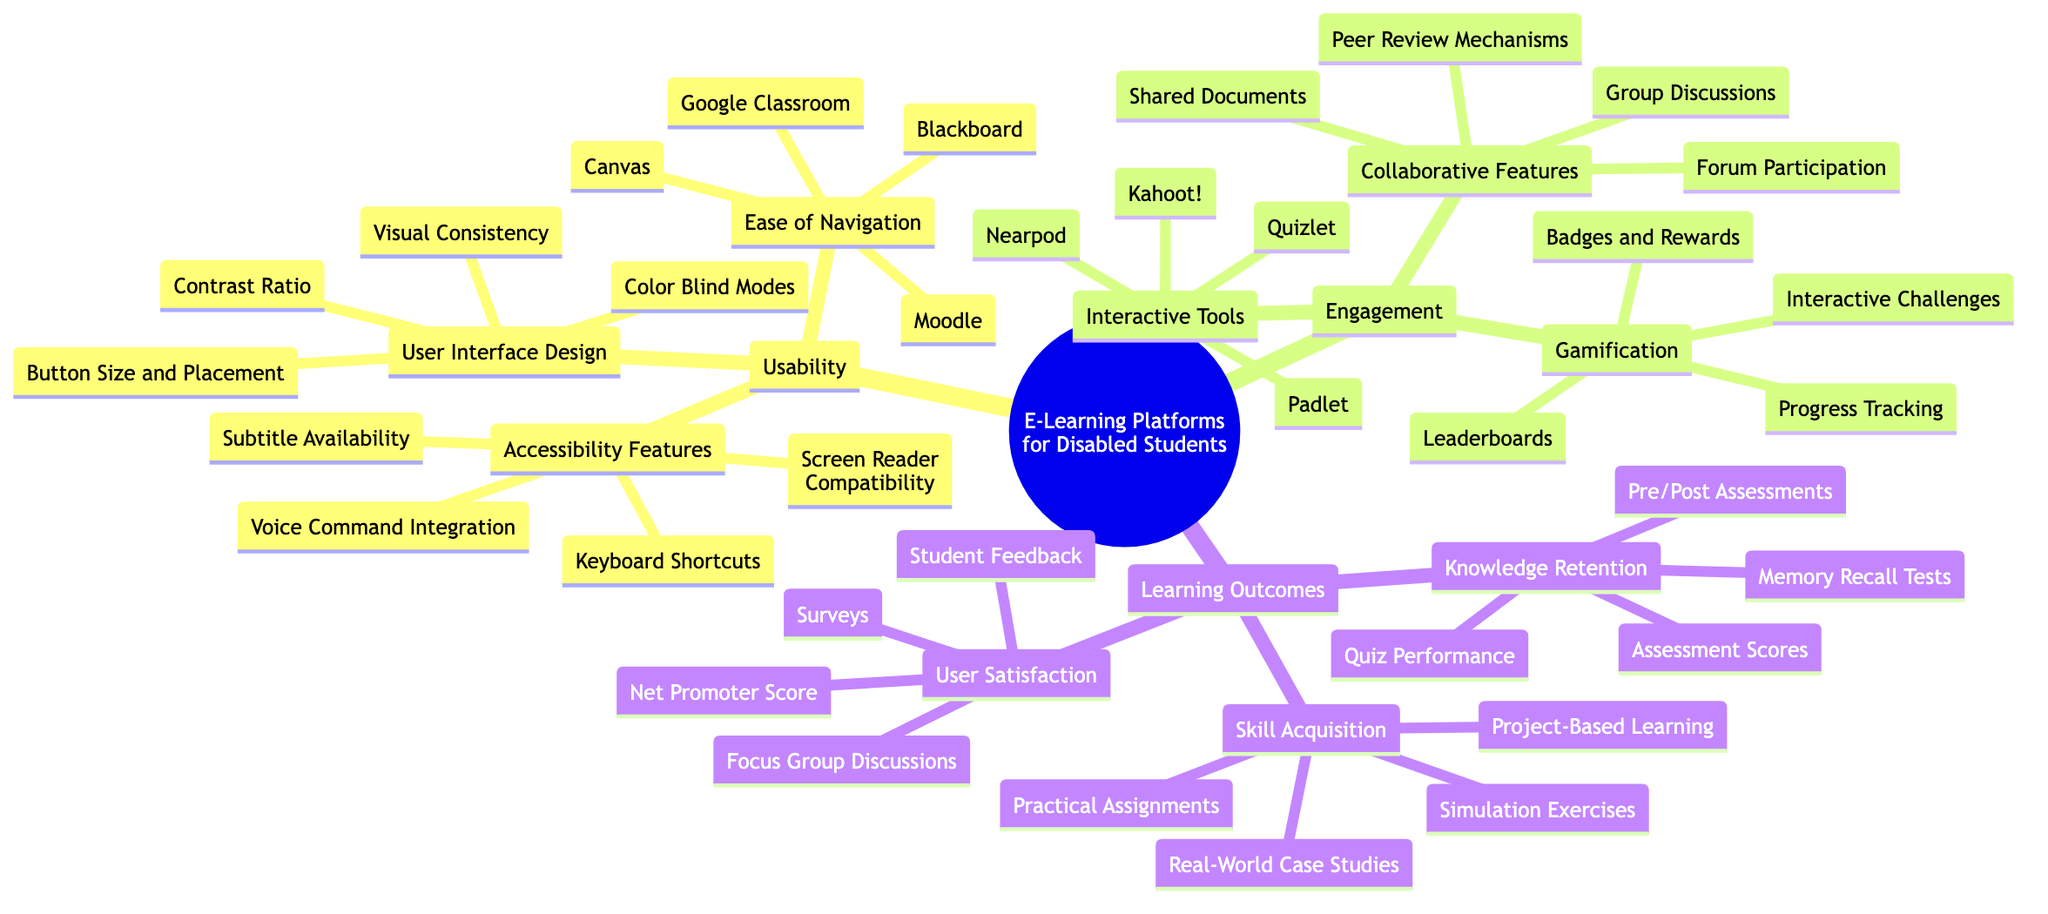What are the main branches of the mind map? The main branches in the mind map are "Usability," "Engagement," and "Learning Outcomes." This is determined by looking at the primary divisions directly stemming from the central topic in the diagram.
Answer: Usability, Engagement, Learning Outcomes Which platform is listed under Ease of Navigation? The platforms listed under "Ease of Navigation" are Moodle, Canvas, Blackboard, and Google Classroom. Each of these platforms is an element beneath this sub-branch, showing specific options in the context of usability.
Answer: Moodle, Canvas, Blackboard, Google Classroom What accessibility feature includes "Subtitle Availability"? "Subtitle Availability" is included under the "Accessibility Features" sub-branch. By examining the relevant section, this feature is explicitly mentioned, tying it to usability for disabled students.
Answer: Accessibility Features How many elements are identified under User Interface Design? There are four elements identified under "User Interface Design": Visual Consistency, Button Size and Placement, Contrast Ratio, and Color Blind Modes. This is counted directly from the listed items in that specific branch.
Answer: 4 Which interactive tools are mentioned for engagement? The interactive tools mentioned for engagement include Quizlet, Kahoot!, Padlet, and Nearpod. Analyzing the "Interactive Tools" sub-branch reveals these specific tools intended to enhance engagement.
Answer: Quizlet, Kahoot!, Padlet, Nearpod What is the first method listed under Knowledge Retention? The first method listed under "Knowledge Retention" is "Pre/Post Assessments." This can be identified by looking at the ordered components of that sub-branch, with "Pre/Post Assessments" appearing at the top.
Answer: Pre/Post Assessments How do you obtain the skill acquisition elements? The elements of skill acquisition are Practical Assignments, Project-Based Learning, Simulation Exercises, and Real-World Case Studies, found by examining the "Skill Acquisition" sub-branch closely.
Answer: Practical Assignments, Project-Based Learning, Simulation Exercises, Real-World Case Studies What is the last element listed under User Satisfaction? The last element listed under "User Satisfaction" is the "Net Promoter Score." By checking the sequence in that sub-branch, it is the fourth item observed.
Answer: Net Promoter Score Which engagement method involves participation in discussions? "Group Discussions" is the engagement method that involves participation in discussions, as listed under "Collaborative Features." It's identified by directly looking at this specific area in the diagram.
Answer: Group Discussions 